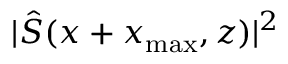Convert formula to latex. <formula><loc_0><loc_0><loc_500><loc_500>| \hat { S } ( x + x _ { \max } , z ) | ^ { 2 }</formula> 